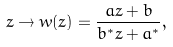Convert formula to latex. <formula><loc_0><loc_0><loc_500><loc_500>z \to w ( z ) = \frac { a z + b } { b ^ { * } z + a ^ { * } } ,</formula> 